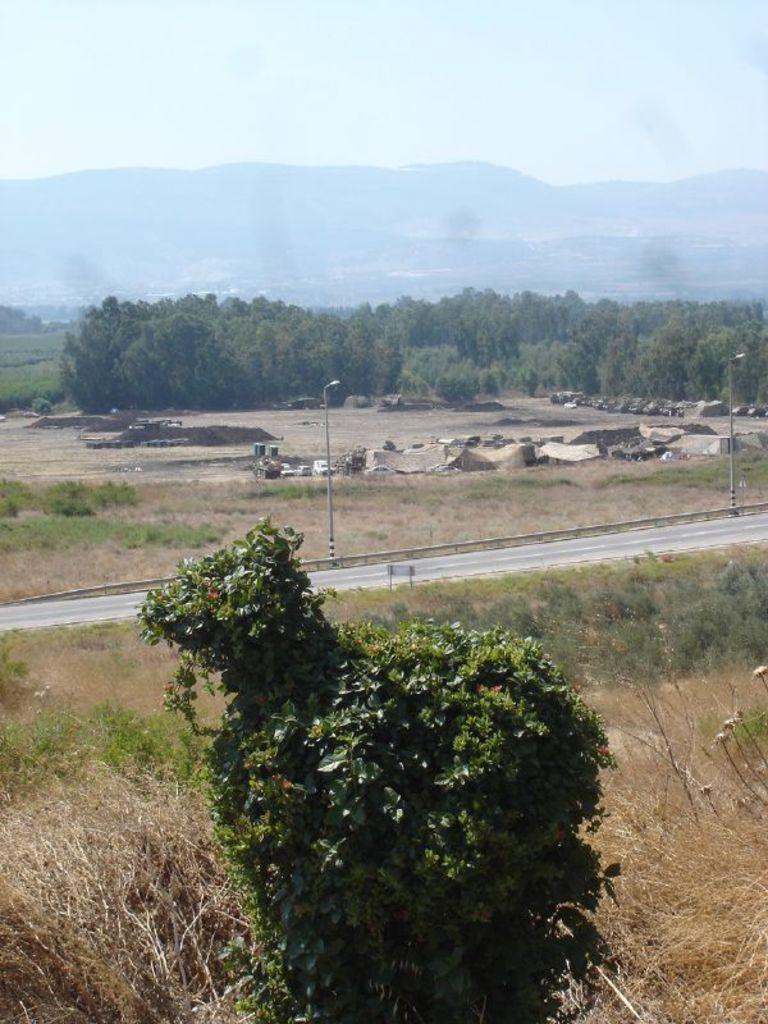In one or two sentences, can you explain what this image depicts? This image clicked outside. In the front, there is a tree and dry grass. In the middle, there is a road. In the background, there are trees and mountains. At the top, there are clouds in the sky. 